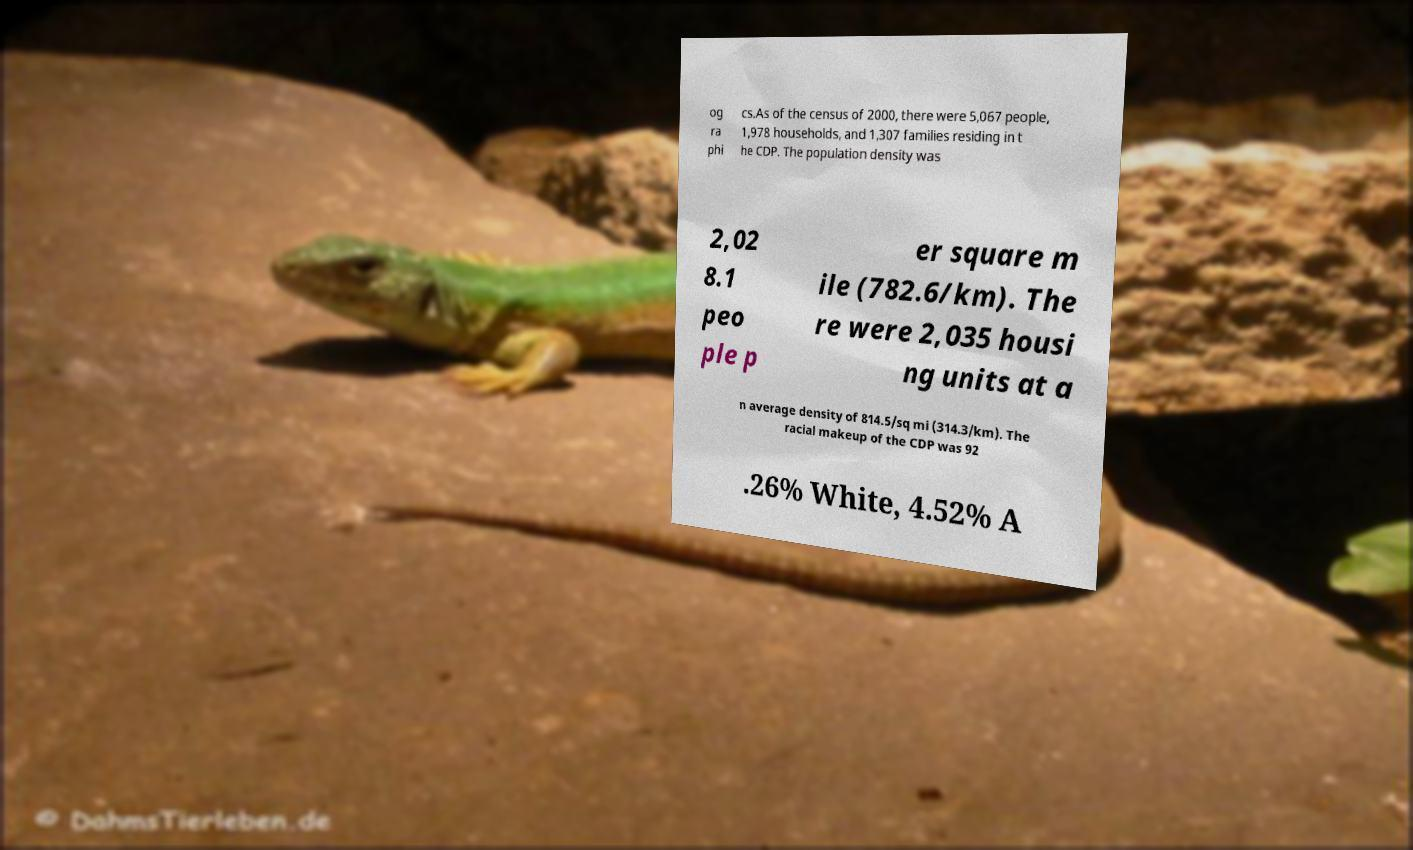I need the written content from this picture converted into text. Can you do that? og ra phi cs.As of the census of 2000, there were 5,067 people, 1,978 households, and 1,307 families residing in t he CDP. The population density was 2,02 8.1 peo ple p er square m ile (782.6/km). The re were 2,035 housi ng units at a n average density of 814.5/sq mi (314.3/km). The racial makeup of the CDP was 92 .26% White, 4.52% A 